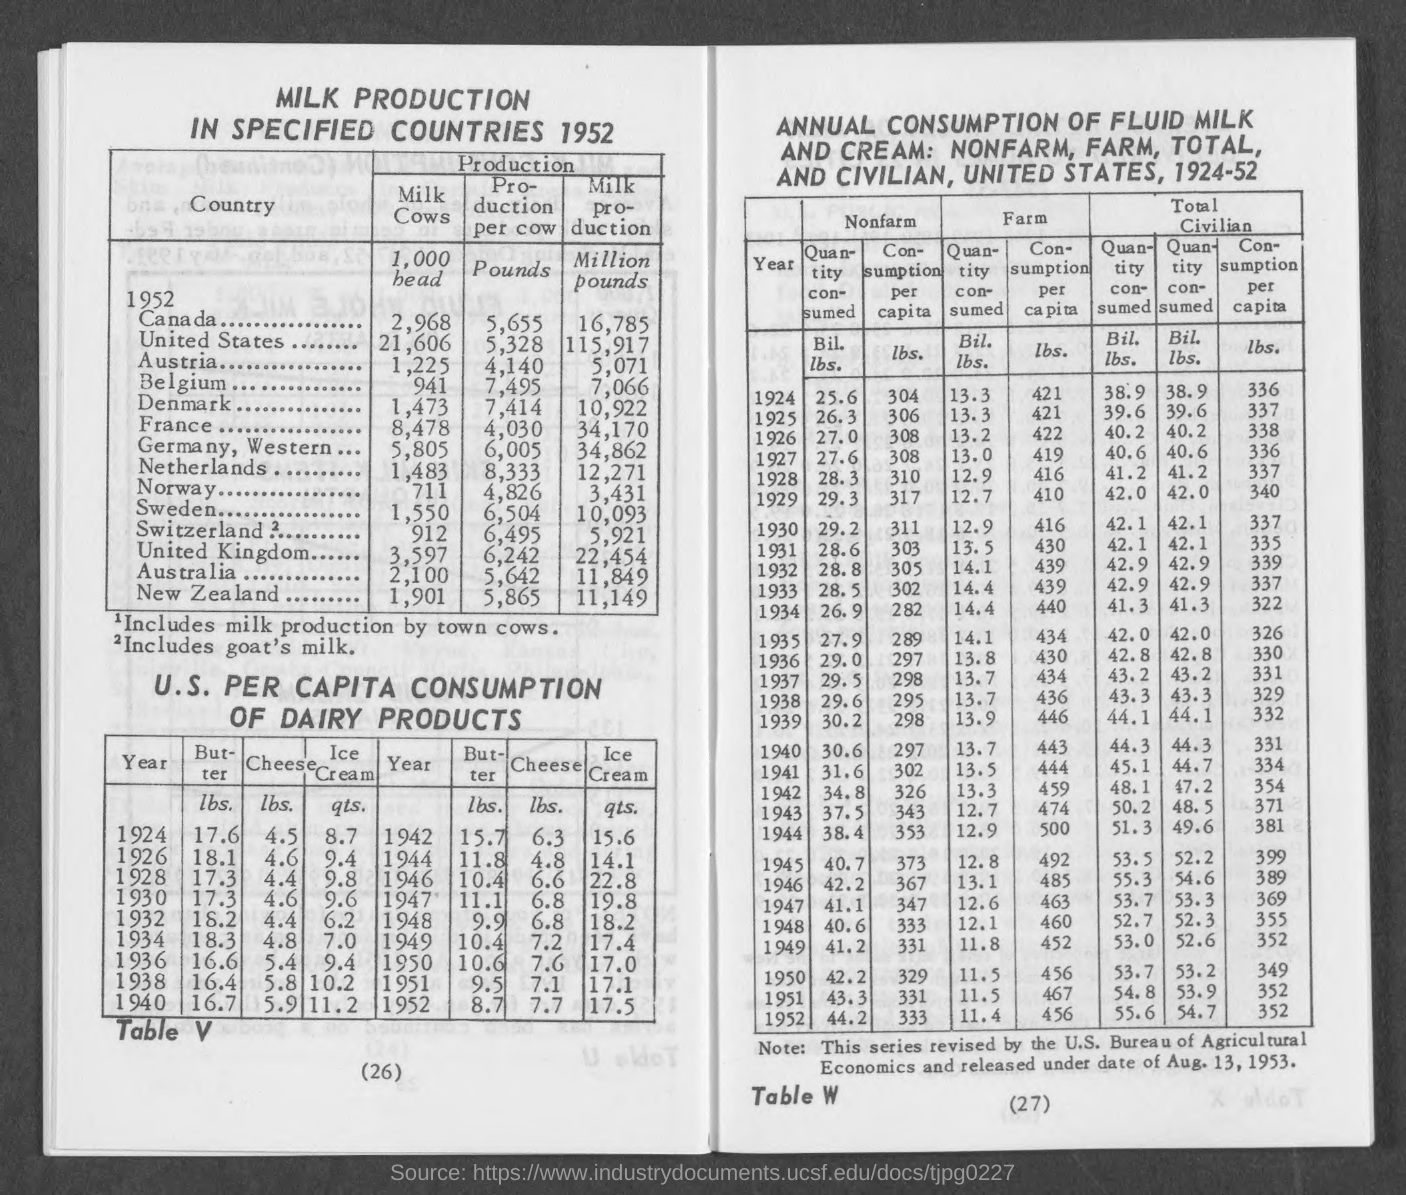List a handful of essential elements in this visual. The number at the bottom right of the page is 27. The average production per cow in the Netherlands is 8,333. The production per cow in Denmark is approximately 7,414. The average production per cow in France is approximately 4,030 pounds. The production per cow in Germany, Western is approximately 6,005. 